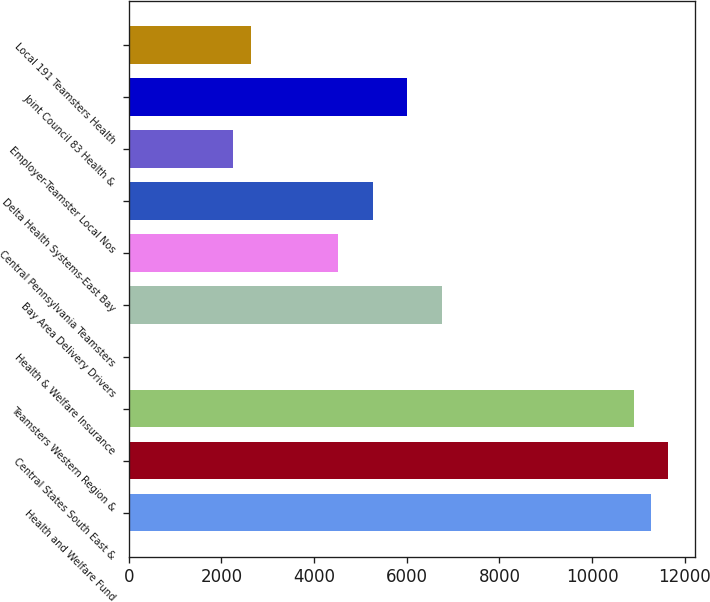Convert chart to OTSL. <chart><loc_0><loc_0><loc_500><loc_500><bar_chart><fcel>Health and Welfare Fund<fcel>Central States South East &<fcel>Teamsters Western Region &<fcel>Health & Welfare Insurance<fcel>Bay Area Delivery Drivers<fcel>Central Pennsylvania Teamsters<fcel>Delta Health Systems-East Bay<fcel>Employer-Teamster Local Nos<fcel>Joint Council 83 Health &<fcel>Local 191 Teamsters Health<nl><fcel>11271<fcel>11646.5<fcel>10895.5<fcel>6<fcel>6765<fcel>4512<fcel>5263<fcel>2259<fcel>6014<fcel>2634.5<nl></chart> 